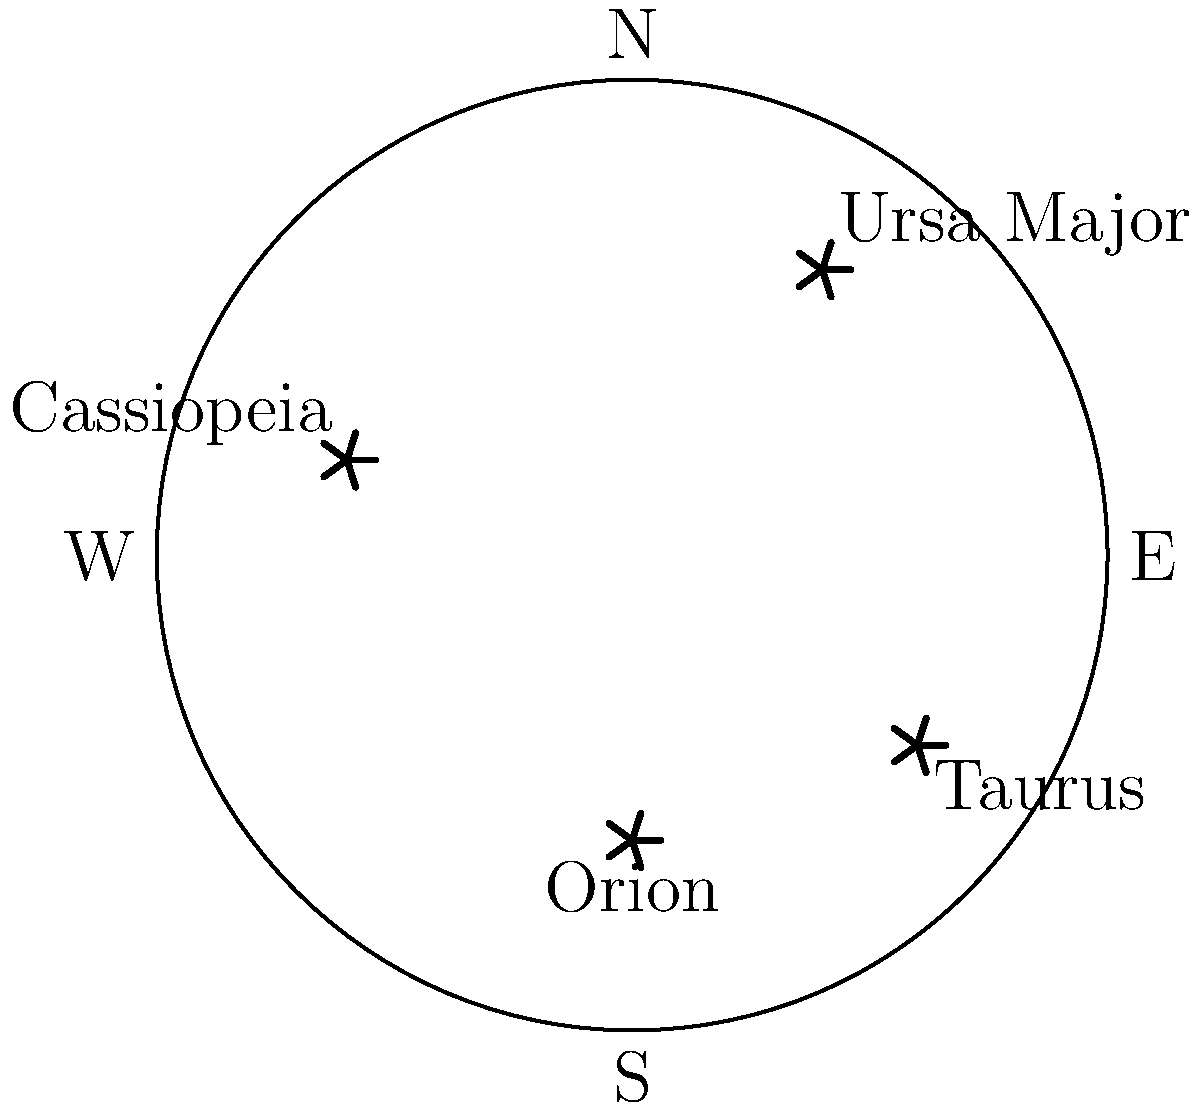During your nights observing the sky in the Chittagong Hill Tracts, which constellation among those shown in the diagram would you typically see lowest on the horizon when facing north? To answer this question, we need to analyze the positions of the constellations in the given star chart:

1. The chart shows a view of the night sky with cardinal directions marked.
2. North (N) is at the top of the circle, and South (S) is at the bottom.
3. Four constellations are marked: Ursa Major, Cassiopeia, Orion, and Taurus.
4. When facing north, we look towards the top of the circle.
5. The constellation closest to the bottom of the circle (South) will appear lowest on the horizon when facing north.
6. Examining the positions:
   - Ursa Major is in the northeast quadrant
   - Cassiopeia is in the northwest quadrant
   - Taurus is in the southeast quadrant
   - Orion is closest to the bottom (South) of the circle
7. Therefore, Orion would appear lowest on the horizon when facing north.

This positioning is consistent with the actual night sky in the Northern Hemisphere, where Orion is a prominent southern constellation.
Answer: Orion 